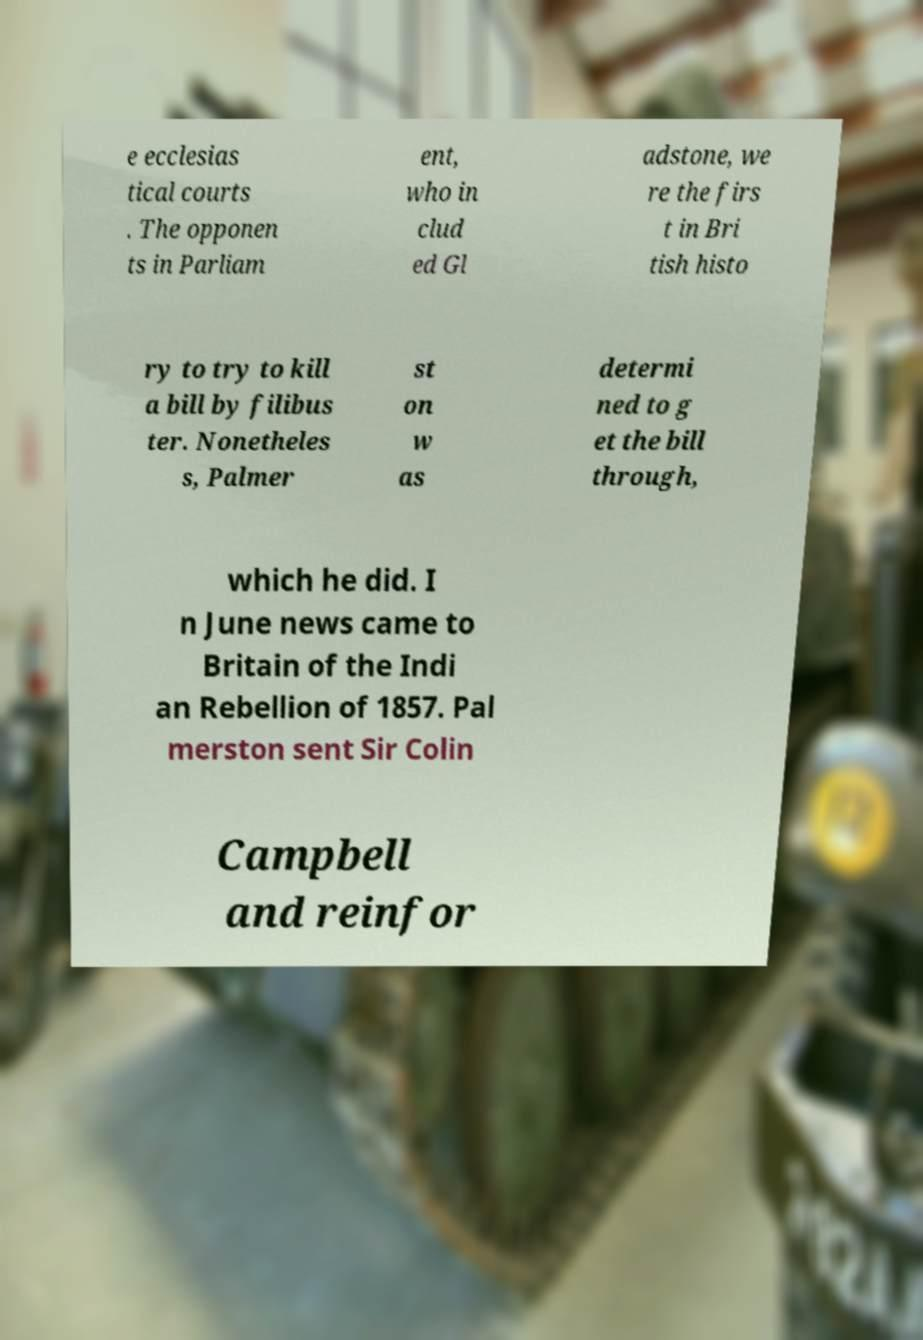Please identify and transcribe the text found in this image. e ecclesias tical courts . The opponen ts in Parliam ent, who in clud ed Gl adstone, we re the firs t in Bri tish histo ry to try to kill a bill by filibus ter. Nonetheles s, Palmer st on w as determi ned to g et the bill through, which he did. I n June news came to Britain of the Indi an Rebellion of 1857. Pal merston sent Sir Colin Campbell and reinfor 